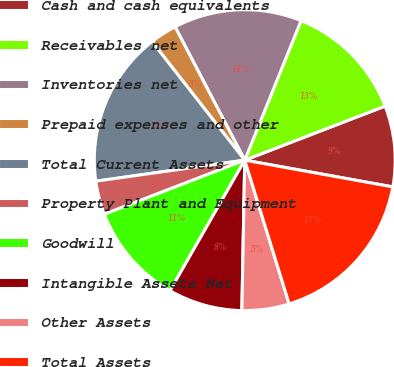Convert chart. <chart><loc_0><loc_0><loc_500><loc_500><pie_chart><fcel>Cash and cash equivalents<fcel>Receivables net<fcel>Inventories net<fcel>Prepaid expenses and other<fcel>Total Current Assets<fcel>Property Plant and Equipment<fcel>Goodwill<fcel>Intangible Assets Net<fcel>Other Assets<fcel>Total Assets<nl><fcel>8.7%<fcel>13.04%<fcel>13.77%<fcel>2.9%<fcel>16.67%<fcel>3.62%<fcel>10.87%<fcel>7.97%<fcel>5.07%<fcel>17.39%<nl></chart> 